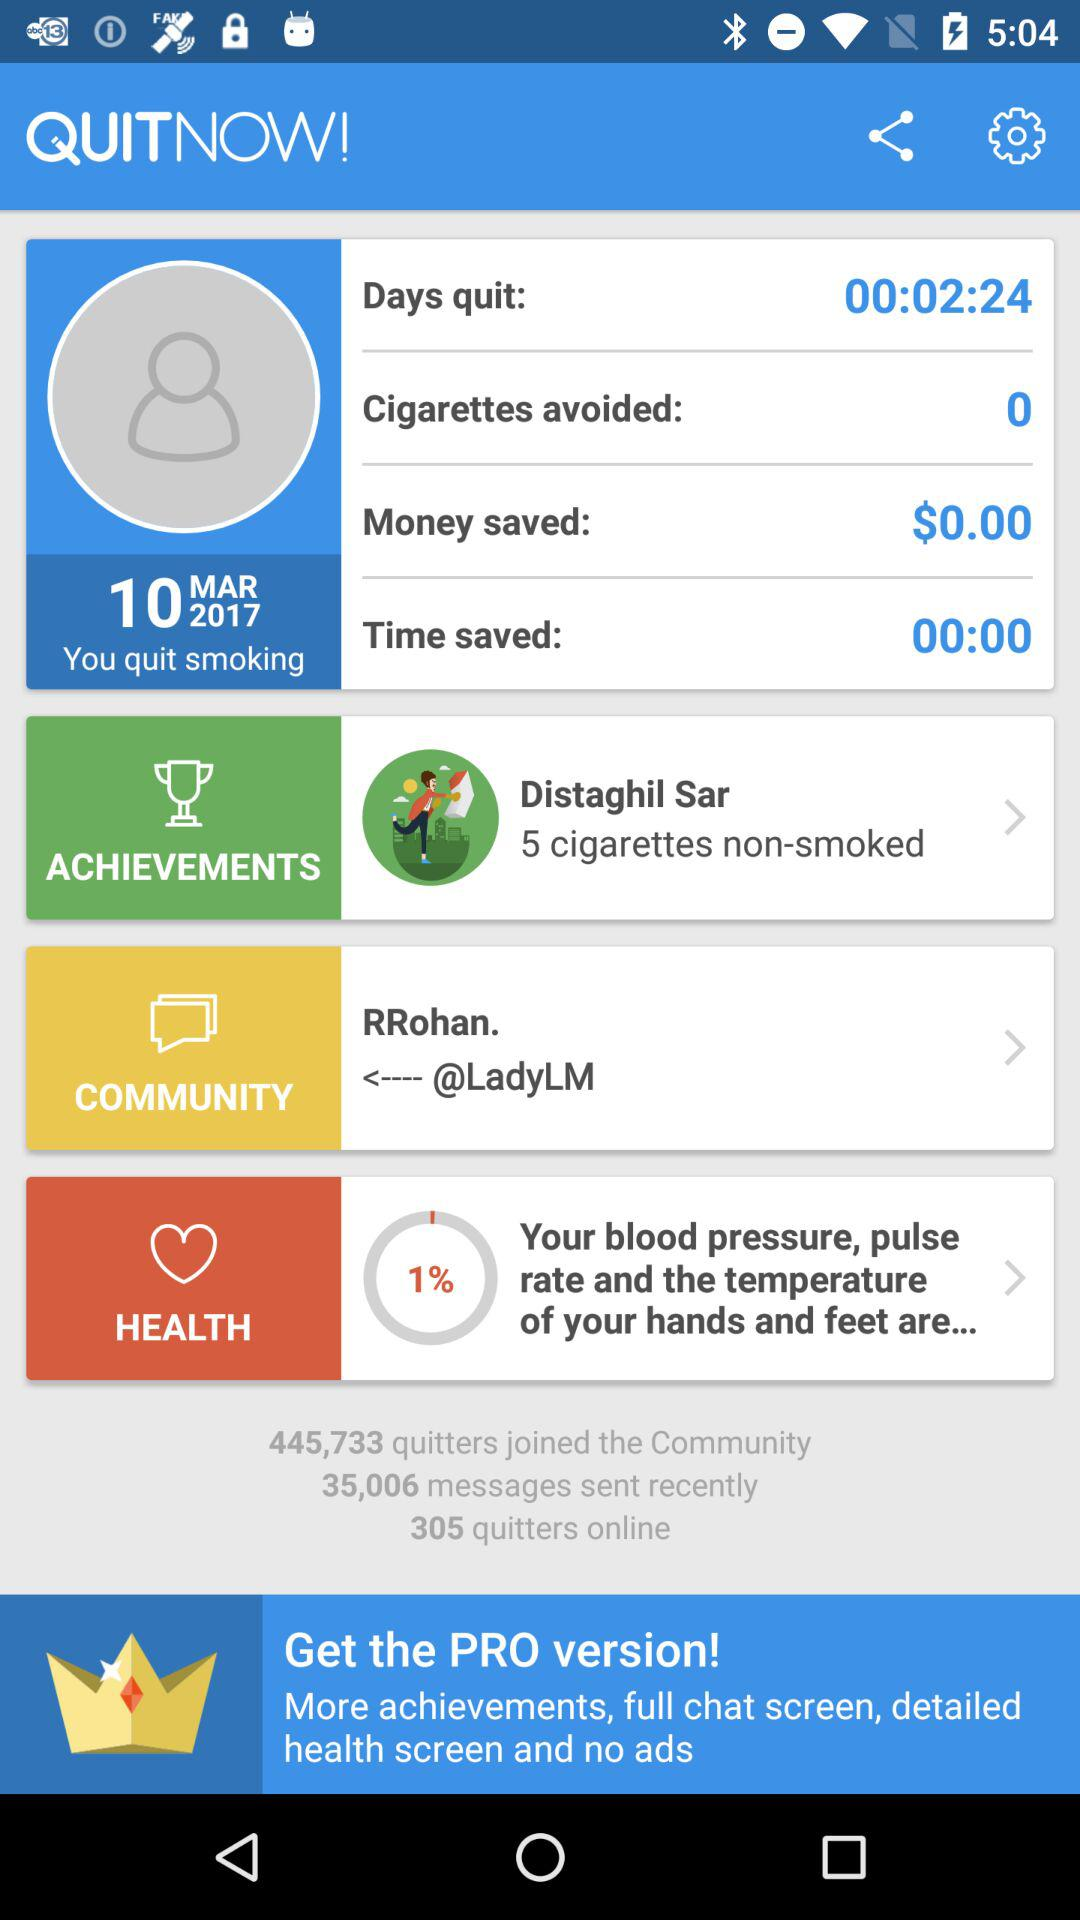How much time has been saved? The time that has been saved is 0 seconds. 